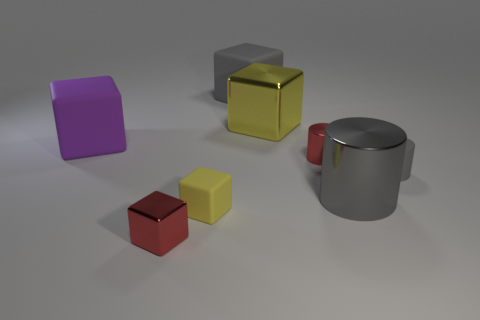Subtract all small cylinders. How many cylinders are left? 1 Subtract all purple cubes. How many cubes are left? 4 Subtract all cylinders. How many objects are left? 5 Subtract 1 cylinders. How many cylinders are left? 2 Subtract all green cubes. How many gray cylinders are left? 2 Add 2 big purple matte blocks. How many objects exist? 10 Subtract 1 yellow blocks. How many objects are left? 7 Subtract all blue cylinders. Subtract all purple spheres. How many cylinders are left? 3 Subtract all big cyan things. Subtract all tiny gray rubber cylinders. How many objects are left? 7 Add 8 large yellow things. How many large yellow things are left? 9 